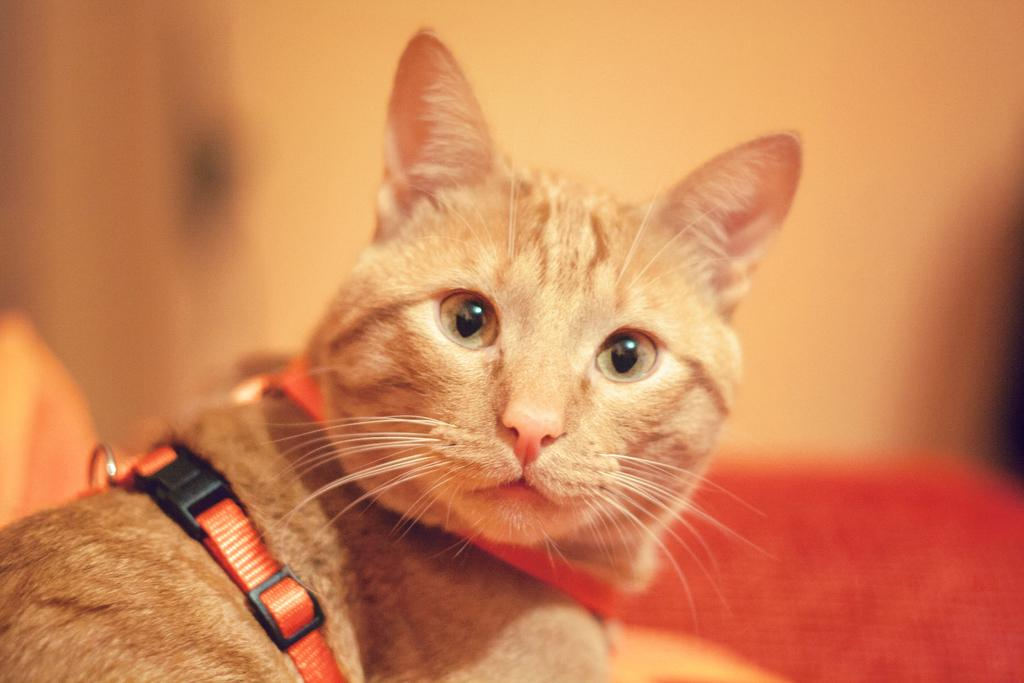What type of animal is in the image? There is a cat in the image. Can you describe the color of the cat? The cat is brown and cream in color. What accessory does the cat have in the image? The cat has a belt in the image. What colors are used for the belt? The belt is orange and black in color. How would you describe the background of the image? The background of the image is blurry. How many sandwiches are on the shelf in the image? There is no shelf or sandwiches present in the image; it features a cat with a belt and a blurry background. 